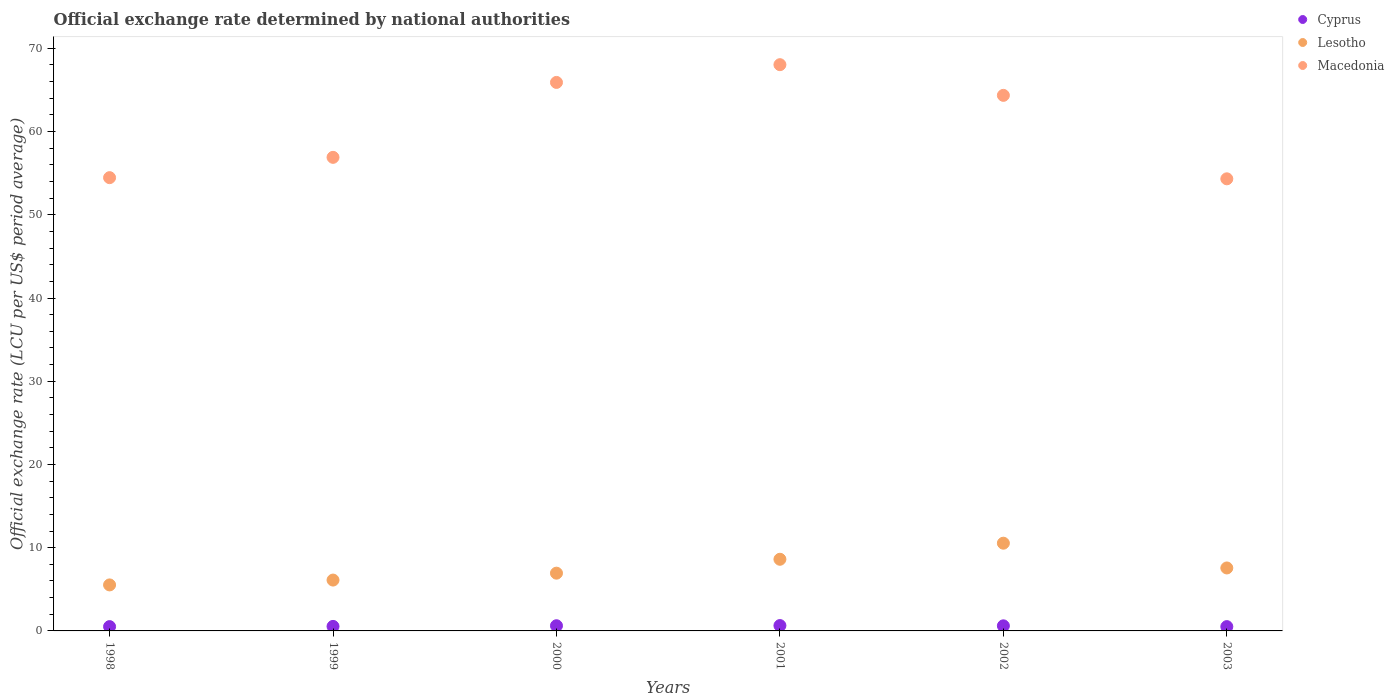How many different coloured dotlines are there?
Provide a succinct answer. 3. Is the number of dotlines equal to the number of legend labels?
Ensure brevity in your answer.  Yes. What is the official exchange rate in Macedonia in 1999?
Provide a short and direct response. 56.9. Across all years, what is the maximum official exchange rate in Lesotho?
Make the answer very short. 10.54. Across all years, what is the minimum official exchange rate in Macedonia?
Keep it short and to the point. 54.32. In which year was the official exchange rate in Macedonia maximum?
Offer a very short reply. 2001. What is the total official exchange rate in Cyprus in the graph?
Give a very brief answer. 3.45. What is the difference between the official exchange rate in Lesotho in 2000 and that in 2002?
Your response must be concise. -3.6. What is the difference between the official exchange rate in Cyprus in 2002 and the official exchange rate in Lesotho in 2003?
Ensure brevity in your answer.  -6.95. What is the average official exchange rate in Lesotho per year?
Your answer should be very brief. 7.55. In the year 2000, what is the difference between the official exchange rate in Lesotho and official exchange rate in Cyprus?
Ensure brevity in your answer.  6.32. What is the ratio of the official exchange rate in Lesotho in 1998 to that in 2003?
Offer a very short reply. 0.73. Is the official exchange rate in Cyprus in 1998 less than that in 2002?
Your answer should be very brief. Yes. What is the difference between the highest and the second highest official exchange rate in Lesotho?
Your response must be concise. 1.93. What is the difference between the highest and the lowest official exchange rate in Cyprus?
Make the answer very short. 0.13. In how many years, is the official exchange rate in Macedonia greater than the average official exchange rate in Macedonia taken over all years?
Give a very brief answer. 3. Does the official exchange rate in Macedonia monotonically increase over the years?
Provide a short and direct response. No. Is the official exchange rate in Macedonia strictly greater than the official exchange rate in Cyprus over the years?
Offer a terse response. Yes. Is the official exchange rate in Macedonia strictly less than the official exchange rate in Cyprus over the years?
Your answer should be compact. No. Does the graph contain any zero values?
Your response must be concise. No. Does the graph contain grids?
Keep it short and to the point. No. What is the title of the graph?
Your answer should be compact. Official exchange rate determined by national authorities. What is the label or title of the Y-axis?
Keep it short and to the point. Official exchange rate (LCU per US$ period average). What is the Official exchange rate (LCU per US$ period average) in Cyprus in 1998?
Offer a terse response. 0.52. What is the Official exchange rate (LCU per US$ period average) in Lesotho in 1998?
Provide a succinct answer. 5.53. What is the Official exchange rate (LCU per US$ period average) of Macedonia in 1998?
Ensure brevity in your answer.  54.46. What is the Official exchange rate (LCU per US$ period average) of Cyprus in 1999?
Give a very brief answer. 0.54. What is the Official exchange rate (LCU per US$ period average) of Lesotho in 1999?
Provide a short and direct response. 6.11. What is the Official exchange rate (LCU per US$ period average) of Macedonia in 1999?
Offer a terse response. 56.9. What is the Official exchange rate (LCU per US$ period average) in Cyprus in 2000?
Your response must be concise. 0.62. What is the Official exchange rate (LCU per US$ period average) in Lesotho in 2000?
Make the answer very short. 6.94. What is the Official exchange rate (LCU per US$ period average) in Macedonia in 2000?
Your answer should be very brief. 65.9. What is the Official exchange rate (LCU per US$ period average) of Cyprus in 2001?
Provide a succinct answer. 0.64. What is the Official exchange rate (LCU per US$ period average) of Lesotho in 2001?
Offer a terse response. 8.61. What is the Official exchange rate (LCU per US$ period average) of Macedonia in 2001?
Your answer should be compact. 68.04. What is the Official exchange rate (LCU per US$ period average) of Cyprus in 2002?
Give a very brief answer. 0.61. What is the Official exchange rate (LCU per US$ period average) in Lesotho in 2002?
Make the answer very short. 10.54. What is the Official exchange rate (LCU per US$ period average) in Macedonia in 2002?
Your response must be concise. 64.35. What is the Official exchange rate (LCU per US$ period average) in Cyprus in 2003?
Your answer should be very brief. 0.52. What is the Official exchange rate (LCU per US$ period average) in Lesotho in 2003?
Offer a terse response. 7.56. What is the Official exchange rate (LCU per US$ period average) of Macedonia in 2003?
Provide a short and direct response. 54.32. Across all years, what is the maximum Official exchange rate (LCU per US$ period average) of Cyprus?
Provide a succinct answer. 0.64. Across all years, what is the maximum Official exchange rate (LCU per US$ period average) of Lesotho?
Keep it short and to the point. 10.54. Across all years, what is the maximum Official exchange rate (LCU per US$ period average) in Macedonia?
Your answer should be compact. 68.04. Across all years, what is the minimum Official exchange rate (LCU per US$ period average) in Cyprus?
Your response must be concise. 0.52. Across all years, what is the minimum Official exchange rate (LCU per US$ period average) in Lesotho?
Your response must be concise. 5.53. Across all years, what is the minimum Official exchange rate (LCU per US$ period average) in Macedonia?
Provide a succinct answer. 54.32. What is the total Official exchange rate (LCU per US$ period average) of Cyprus in the graph?
Your answer should be compact. 3.45. What is the total Official exchange rate (LCU per US$ period average) in Lesotho in the graph?
Provide a succinct answer. 45.29. What is the total Official exchange rate (LCU per US$ period average) in Macedonia in the graph?
Your response must be concise. 363.98. What is the difference between the Official exchange rate (LCU per US$ period average) of Cyprus in 1998 and that in 1999?
Provide a succinct answer. -0.03. What is the difference between the Official exchange rate (LCU per US$ period average) in Lesotho in 1998 and that in 1999?
Keep it short and to the point. -0.58. What is the difference between the Official exchange rate (LCU per US$ period average) in Macedonia in 1998 and that in 1999?
Offer a very short reply. -2.44. What is the difference between the Official exchange rate (LCU per US$ period average) in Cyprus in 1998 and that in 2000?
Provide a succinct answer. -0.1. What is the difference between the Official exchange rate (LCU per US$ period average) in Lesotho in 1998 and that in 2000?
Your answer should be very brief. -1.41. What is the difference between the Official exchange rate (LCU per US$ period average) of Macedonia in 1998 and that in 2000?
Offer a terse response. -11.44. What is the difference between the Official exchange rate (LCU per US$ period average) in Cyprus in 1998 and that in 2001?
Provide a short and direct response. -0.13. What is the difference between the Official exchange rate (LCU per US$ period average) of Lesotho in 1998 and that in 2001?
Ensure brevity in your answer.  -3.08. What is the difference between the Official exchange rate (LCU per US$ period average) in Macedonia in 1998 and that in 2001?
Your answer should be compact. -13.58. What is the difference between the Official exchange rate (LCU per US$ period average) of Cyprus in 1998 and that in 2002?
Keep it short and to the point. -0.09. What is the difference between the Official exchange rate (LCU per US$ period average) of Lesotho in 1998 and that in 2002?
Your response must be concise. -5.01. What is the difference between the Official exchange rate (LCU per US$ period average) of Macedonia in 1998 and that in 2002?
Give a very brief answer. -9.89. What is the difference between the Official exchange rate (LCU per US$ period average) in Lesotho in 1998 and that in 2003?
Your answer should be very brief. -2.04. What is the difference between the Official exchange rate (LCU per US$ period average) in Macedonia in 1998 and that in 2003?
Give a very brief answer. 0.14. What is the difference between the Official exchange rate (LCU per US$ period average) of Cyprus in 1999 and that in 2000?
Ensure brevity in your answer.  -0.08. What is the difference between the Official exchange rate (LCU per US$ period average) in Lesotho in 1999 and that in 2000?
Your response must be concise. -0.83. What is the difference between the Official exchange rate (LCU per US$ period average) in Macedonia in 1999 and that in 2000?
Your response must be concise. -9. What is the difference between the Official exchange rate (LCU per US$ period average) in Cyprus in 1999 and that in 2001?
Your answer should be very brief. -0.1. What is the difference between the Official exchange rate (LCU per US$ period average) in Lesotho in 1999 and that in 2001?
Offer a very short reply. -2.5. What is the difference between the Official exchange rate (LCU per US$ period average) in Macedonia in 1999 and that in 2001?
Provide a short and direct response. -11.14. What is the difference between the Official exchange rate (LCU per US$ period average) in Cyprus in 1999 and that in 2002?
Provide a succinct answer. -0.07. What is the difference between the Official exchange rate (LCU per US$ period average) in Lesotho in 1999 and that in 2002?
Your answer should be very brief. -4.43. What is the difference between the Official exchange rate (LCU per US$ period average) of Macedonia in 1999 and that in 2002?
Provide a short and direct response. -7.45. What is the difference between the Official exchange rate (LCU per US$ period average) of Cyprus in 1999 and that in 2003?
Offer a terse response. 0.03. What is the difference between the Official exchange rate (LCU per US$ period average) in Lesotho in 1999 and that in 2003?
Your answer should be compact. -1.46. What is the difference between the Official exchange rate (LCU per US$ period average) in Macedonia in 1999 and that in 2003?
Your answer should be compact. 2.58. What is the difference between the Official exchange rate (LCU per US$ period average) in Cyprus in 2000 and that in 2001?
Your answer should be compact. -0.02. What is the difference between the Official exchange rate (LCU per US$ period average) of Lesotho in 2000 and that in 2001?
Provide a succinct answer. -1.67. What is the difference between the Official exchange rate (LCU per US$ period average) of Macedonia in 2000 and that in 2001?
Offer a terse response. -2.13. What is the difference between the Official exchange rate (LCU per US$ period average) of Cyprus in 2000 and that in 2002?
Provide a short and direct response. 0.01. What is the difference between the Official exchange rate (LCU per US$ period average) in Lesotho in 2000 and that in 2002?
Ensure brevity in your answer.  -3.6. What is the difference between the Official exchange rate (LCU per US$ period average) of Macedonia in 2000 and that in 2002?
Offer a terse response. 1.55. What is the difference between the Official exchange rate (LCU per US$ period average) of Cyprus in 2000 and that in 2003?
Provide a succinct answer. 0.1. What is the difference between the Official exchange rate (LCU per US$ period average) of Lesotho in 2000 and that in 2003?
Keep it short and to the point. -0.62. What is the difference between the Official exchange rate (LCU per US$ period average) in Macedonia in 2000 and that in 2003?
Offer a terse response. 11.58. What is the difference between the Official exchange rate (LCU per US$ period average) in Cyprus in 2001 and that in 2002?
Ensure brevity in your answer.  0.03. What is the difference between the Official exchange rate (LCU per US$ period average) in Lesotho in 2001 and that in 2002?
Make the answer very short. -1.93. What is the difference between the Official exchange rate (LCU per US$ period average) in Macedonia in 2001 and that in 2002?
Your answer should be compact. 3.69. What is the difference between the Official exchange rate (LCU per US$ period average) of Cyprus in 2001 and that in 2003?
Your answer should be compact. 0.13. What is the difference between the Official exchange rate (LCU per US$ period average) in Lesotho in 2001 and that in 2003?
Keep it short and to the point. 1.04. What is the difference between the Official exchange rate (LCU per US$ period average) of Macedonia in 2001 and that in 2003?
Your answer should be compact. 13.71. What is the difference between the Official exchange rate (LCU per US$ period average) in Cyprus in 2002 and that in 2003?
Make the answer very short. 0.09. What is the difference between the Official exchange rate (LCU per US$ period average) of Lesotho in 2002 and that in 2003?
Your response must be concise. 2.98. What is the difference between the Official exchange rate (LCU per US$ period average) of Macedonia in 2002 and that in 2003?
Offer a terse response. 10.03. What is the difference between the Official exchange rate (LCU per US$ period average) of Cyprus in 1998 and the Official exchange rate (LCU per US$ period average) of Lesotho in 1999?
Provide a short and direct response. -5.59. What is the difference between the Official exchange rate (LCU per US$ period average) in Cyprus in 1998 and the Official exchange rate (LCU per US$ period average) in Macedonia in 1999?
Your answer should be compact. -56.38. What is the difference between the Official exchange rate (LCU per US$ period average) in Lesotho in 1998 and the Official exchange rate (LCU per US$ period average) in Macedonia in 1999?
Your response must be concise. -51.37. What is the difference between the Official exchange rate (LCU per US$ period average) of Cyprus in 1998 and the Official exchange rate (LCU per US$ period average) of Lesotho in 2000?
Provide a succinct answer. -6.42. What is the difference between the Official exchange rate (LCU per US$ period average) in Cyprus in 1998 and the Official exchange rate (LCU per US$ period average) in Macedonia in 2000?
Offer a terse response. -65.39. What is the difference between the Official exchange rate (LCU per US$ period average) in Lesotho in 1998 and the Official exchange rate (LCU per US$ period average) in Macedonia in 2000?
Give a very brief answer. -60.38. What is the difference between the Official exchange rate (LCU per US$ period average) of Cyprus in 1998 and the Official exchange rate (LCU per US$ period average) of Lesotho in 2001?
Your answer should be compact. -8.09. What is the difference between the Official exchange rate (LCU per US$ period average) of Cyprus in 1998 and the Official exchange rate (LCU per US$ period average) of Macedonia in 2001?
Provide a succinct answer. -67.52. What is the difference between the Official exchange rate (LCU per US$ period average) of Lesotho in 1998 and the Official exchange rate (LCU per US$ period average) of Macedonia in 2001?
Provide a succinct answer. -62.51. What is the difference between the Official exchange rate (LCU per US$ period average) in Cyprus in 1998 and the Official exchange rate (LCU per US$ period average) in Lesotho in 2002?
Keep it short and to the point. -10.02. What is the difference between the Official exchange rate (LCU per US$ period average) in Cyprus in 1998 and the Official exchange rate (LCU per US$ period average) in Macedonia in 2002?
Your answer should be compact. -63.83. What is the difference between the Official exchange rate (LCU per US$ period average) of Lesotho in 1998 and the Official exchange rate (LCU per US$ period average) of Macedonia in 2002?
Make the answer very short. -58.82. What is the difference between the Official exchange rate (LCU per US$ period average) in Cyprus in 1998 and the Official exchange rate (LCU per US$ period average) in Lesotho in 2003?
Ensure brevity in your answer.  -7.05. What is the difference between the Official exchange rate (LCU per US$ period average) in Cyprus in 1998 and the Official exchange rate (LCU per US$ period average) in Macedonia in 2003?
Provide a short and direct response. -53.8. What is the difference between the Official exchange rate (LCU per US$ period average) of Lesotho in 1998 and the Official exchange rate (LCU per US$ period average) of Macedonia in 2003?
Keep it short and to the point. -48.79. What is the difference between the Official exchange rate (LCU per US$ period average) in Cyprus in 1999 and the Official exchange rate (LCU per US$ period average) in Lesotho in 2000?
Provide a succinct answer. -6.4. What is the difference between the Official exchange rate (LCU per US$ period average) in Cyprus in 1999 and the Official exchange rate (LCU per US$ period average) in Macedonia in 2000?
Provide a short and direct response. -65.36. What is the difference between the Official exchange rate (LCU per US$ period average) in Lesotho in 1999 and the Official exchange rate (LCU per US$ period average) in Macedonia in 2000?
Provide a short and direct response. -59.79. What is the difference between the Official exchange rate (LCU per US$ period average) in Cyprus in 1999 and the Official exchange rate (LCU per US$ period average) in Lesotho in 2001?
Offer a very short reply. -8.07. What is the difference between the Official exchange rate (LCU per US$ period average) of Cyprus in 1999 and the Official exchange rate (LCU per US$ period average) of Macedonia in 2001?
Offer a very short reply. -67.49. What is the difference between the Official exchange rate (LCU per US$ period average) of Lesotho in 1999 and the Official exchange rate (LCU per US$ period average) of Macedonia in 2001?
Offer a terse response. -61.93. What is the difference between the Official exchange rate (LCU per US$ period average) of Cyprus in 1999 and the Official exchange rate (LCU per US$ period average) of Lesotho in 2002?
Give a very brief answer. -10. What is the difference between the Official exchange rate (LCU per US$ period average) in Cyprus in 1999 and the Official exchange rate (LCU per US$ period average) in Macedonia in 2002?
Offer a very short reply. -63.81. What is the difference between the Official exchange rate (LCU per US$ period average) in Lesotho in 1999 and the Official exchange rate (LCU per US$ period average) in Macedonia in 2002?
Your answer should be compact. -58.24. What is the difference between the Official exchange rate (LCU per US$ period average) in Cyprus in 1999 and the Official exchange rate (LCU per US$ period average) in Lesotho in 2003?
Offer a very short reply. -7.02. What is the difference between the Official exchange rate (LCU per US$ period average) of Cyprus in 1999 and the Official exchange rate (LCU per US$ period average) of Macedonia in 2003?
Give a very brief answer. -53.78. What is the difference between the Official exchange rate (LCU per US$ period average) of Lesotho in 1999 and the Official exchange rate (LCU per US$ period average) of Macedonia in 2003?
Your answer should be compact. -48.21. What is the difference between the Official exchange rate (LCU per US$ period average) in Cyprus in 2000 and the Official exchange rate (LCU per US$ period average) in Lesotho in 2001?
Ensure brevity in your answer.  -7.99. What is the difference between the Official exchange rate (LCU per US$ period average) in Cyprus in 2000 and the Official exchange rate (LCU per US$ period average) in Macedonia in 2001?
Your answer should be very brief. -67.41. What is the difference between the Official exchange rate (LCU per US$ period average) of Lesotho in 2000 and the Official exchange rate (LCU per US$ period average) of Macedonia in 2001?
Your response must be concise. -61.1. What is the difference between the Official exchange rate (LCU per US$ period average) in Cyprus in 2000 and the Official exchange rate (LCU per US$ period average) in Lesotho in 2002?
Your response must be concise. -9.92. What is the difference between the Official exchange rate (LCU per US$ period average) of Cyprus in 2000 and the Official exchange rate (LCU per US$ period average) of Macedonia in 2002?
Provide a short and direct response. -63.73. What is the difference between the Official exchange rate (LCU per US$ period average) in Lesotho in 2000 and the Official exchange rate (LCU per US$ period average) in Macedonia in 2002?
Your answer should be compact. -57.41. What is the difference between the Official exchange rate (LCU per US$ period average) in Cyprus in 2000 and the Official exchange rate (LCU per US$ period average) in Lesotho in 2003?
Give a very brief answer. -6.94. What is the difference between the Official exchange rate (LCU per US$ period average) of Cyprus in 2000 and the Official exchange rate (LCU per US$ period average) of Macedonia in 2003?
Provide a succinct answer. -53.7. What is the difference between the Official exchange rate (LCU per US$ period average) of Lesotho in 2000 and the Official exchange rate (LCU per US$ period average) of Macedonia in 2003?
Offer a very short reply. -47.38. What is the difference between the Official exchange rate (LCU per US$ period average) of Cyprus in 2001 and the Official exchange rate (LCU per US$ period average) of Lesotho in 2002?
Your answer should be very brief. -9.9. What is the difference between the Official exchange rate (LCU per US$ period average) of Cyprus in 2001 and the Official exchange rate (LCU per US$ period average) of Macedonia in 2002?
Provide a short and direct response. -63.71. What is the difference between the Official exchange rate (LCU per US$ period average) of Lesotho in 2001 and the Official exchange rate (LCU per US$ period average) of Macedonia in 2002?
Your answer should be very brief. -55.74. What is the difference between the Official exchange rate (LCU per US$ period average) of Cyprus in 2001 and the Official exchange rate (LCU per US$ period average) of Lesotho in 2003?
Your answer should be compact. -6.92. What is the difference between the Official exchange rate (LCU per US$ period average) in Cyprus in 2001 and the Official exchange rate (LCU per US$ period average) in Macedonia in 2003?
Your answer should be very brief. -53.68. What is the difference between the Official exchange rate (LCU per US$ period average) in Lesotho in 2001 and the Official exchange rate (LCU per US$ period average) in Macedonia in 2003?
Your answer should be compact. -45.71. What is the difference between the Official exchange rate (LCU per US$ period average) of Cyprus in 2002 and the Official exchange rate (LCU per US$ period average) of Lesotho in 2003?
Make the answer very short. -6.95. What is the difference between the Official exchange rate (LCU per US$ period average) in Cyprus in 2002 and the Official exchange rate (LCU per US$ period average) in Macedonia in 2003?
Keep it short and to the point. -53.71. What is the difference between the Official exchange rate (LCU per US$ period average) in Lesotho in 2002 and the Official exchange rate (LCU per US$ period average) in Macedonia in 2003?
Provide a short and direct response. -43.78. What is the average Official exchange rate (LCU per US$ period average) of Cyprus per year?
Ensure brevity in your answer.  0.58. What is the average Official exchange rate (LCU per US$ period average) in Lesotho per year?
Make the answer very short. 7.55. What is the average Official exchange rate (LCU per US$ period average) in Macedonia per year?
Offer a very short reply. 60.66. In the year 1998, what is the difference between the Official exchange rate (LCU per US$ period average) of Cyprus and Official exchange rate (LCU per US$ period average) of Lesotho?
Offer a terse response. -5.01. In the year 1998, what is the difference between the Official exchange rate (LCU per US$ period average) of Cyprus and Official exchange rate (LCU per US$ period average) of Macedonia?
Your answer should be very brief. -53.94. In the year 1998, what is the difference between the Official exchange rate (LCU per US$ period average) in Lesotho and Official exchange rate (LCU per US$ period average) in Macedonia?
Your answer should be compact. -48.93. In the year 1999, what is the difference between the Official exchange rate (LCU per US$ period average) of Cyprus and Official exchange rate (LCU per US$ period average) of Lesotho?
Provide a succinct answer. -5.57. In the year 1999, what is the difference between the Official exchange rate (LCU per US$ period average) in Cyprus and Official exchange rate (LCU per US$ period average) in Macedonia?
Ensure brevity in your answer.  -56.36. In the year 1999, what is the difference between the Official exchange rate (LCU per US$ period average) in Lesotho and Official exchange rate (LCU per US$ period average) in Macedonia?
Keep it short and to the point. -50.79. In the year 2000, what is the difference between the Official exchange rate (LCU per US$ period average) in Cyprus and Official exchange rate (LCU per US$ period average) in Lesotho?
Your response must be concise. -6.32. In the year 2000, what is the difference between the Official exchange rate (LCU per US$ period average) of Cyprus and Official exchange rate (LCU per US$ period average) of Macedonia?
Provide a succinct answer. -65.28. In the year 2000, what is the difference between the Official exchange rate (LCU per US$ period average) in Lesotho and Official exchange rate (LCU per US$ period average) in Macedonia?
Give a very brief answer. -58.96. In the year 2001, what is the difference between the Official exchange rate (LCU per US$ period average) in Cyprus and Official exchange rate (LCU per US$ period average) in Lesotho?
Give a very brief answer. -7.97. In the year 2001, what is the difference between the Official exchange rate (LCU per US$ period average) of Cyprus and Official exchange rate (LCU per US$ period average) of Macedonia?
Offer a terse response. -67.39. In the year 2001, what is the difference between the Official exchange rate (LCU per US$ period average) in Lesotho and Official exchange rate (LCU per US$ period average) in Macedonia?
Your answer should be very brief. -59.43. In the year 2002, what is the difference between the Official exchange rate (LCU per US$ period average) of Cyprus and Official exchange rate (LCU per US$ period average) of Lesotho?
Provide a succinct answer. -9.93. In the year 2002, what is the difference between the Official exchange rate (LCU per US$ period average) in Cyprus and Official exchange rate (LCU per US$ period average) in Macedonia?
Your answer should be compact. -63.74. In the year 2002, what is the difference between the Official exchange rate (LCU per US$ period average) in Lesotho and Official exchange rate (LCU per US$ period average) in Macedonia?
Give a very brief answer. -53.81. In the year 2003, what is the difference between the Official exchange rate (LCU per US$ period average) in Cyprus and Official exchange rate (LCU per US$ period average) in Lesotho?
Your response must be concise. -7.05. In the year 2003, what is the difference between the Official exchange rate (LCU per US$ period average) in Cyprus and Official exchange rate (LCU per US$ period average) in Macedonia?
Ensure brevity in your answer.  -53.8. In the year 2003, what is the difference between the Official exchange rate (LCU per US$ period average) of Lesotho and Official exchange rate (LCU per US$ period average) of Macedonia?
Offer a very short reply. -46.76. What is the ratio of the Official exchange rate (LCU per US$ period average) of Cyprus in 1998 to that in 1999?
Give a very brief answer. 0.95. What is the ratio of the Official exchange rate (LCU per US$ period average) of Lesotho in 1998 to that in 1999?
Your response must be concise. 0.9. What is the ratio of the Official exchange rate (LCU per US$ period average) of Macedonia in 1998 to that in 1999?
Your response must be concise. 0.96. What is the ratio of the Official exchange rate (LCU per US$ period average) of Cyprus in 1998 to that in 2000?
Provide a succinct answer. 0.83. What is the ratio of the Official exchange rate (LCU per US$ period average) in Lesotho in 1998 to that in 2000?
Your response must be concise. 0.8. What is the ratio of the Official exchange rate (LCU per US$ period average) in Macedonia in 1998 to that in 2000?
Your response must be concise. 0.83. What is the ratio of the Official exchange rate (LCU per US$ period average) in Cyprus in 1998 to that in 2001?
Make the answer very short. 0.81. What is the ratio of the Official exchange rate (LCU per US$ period average) of Lesotho in 1998 to that in 2001?
Keep it short and to the point. 0.64. What is the ratio of the Official exchange rate (LCU per US$ period average) in Macedonia in 1998 to that in 2001?
Provide a short and direct response. 0.8. What is the ratio of the Official exchange rate (LCU per US$ period average) of Cyprus in 1998 to that in 2002?
Provide a succinct answer. 0.85. What is the ratio of the Official exchange rate (LCU per US$ period average) of Lesotho in 1998 to that in 2002?
Keep it short and to the point. 0.52. What is the ratio of the Official exchange rate (LCU per US$ period average) of Macedonia in 1998 to that in 2002?
Ensure brevity in your answer.  0.85. What is the ratio of the Official exchange rate (LCU per US$ period average) of Cyprus in 1998 to that in 2003?
Your response must be concise. 1. What is the ratio of the Official exchange rate (LCU per US$ period average) in Lesotho in 1998 to that in 2003?
Your response must be concise. 0.73. What is the ratio of the Official exchange rate (LCU per US$ period average) of Cyprus in 1999 to that in 2000?
Make the answer very short. 0.87. What is the ratio of the Official exchange rate (LCU per US$ period average) in Lesotho in 1999 to that in 2000?
Your answer should be very brief. 0.88. What is the ratio of the Official exchange rate (LCU per US$ period average) in Macedonia in 1999 to that in 2000?
Provide a short and direct response. 0.86. What is the ratio of the Official exchange rate (LCU per US$ period average) of Cyprus in 1999 to that in 2001?
Offer a very short reply. 0.84. What is the ratio of the Official exchange rate (LCU per US$ period average) of Lesotho in 1999 to that in 2001?
Keep it short and to the point. 0.71. What is the ratio of the Official exchange rate (LCU per US$ period average) in Macedonia in 1999 to that in 2001?
Ensure brevity in your answer.  0.84. What is the ratio of the Official exchange rate (LCU per US$ period average) in Cyprus in 1999 to that in 2002?
Offer a terse response. 0.89. What is the ratio of the Official exchange rate (LCU per US$ period average) of Lesotho in 1999 to that in 2002?
Provide a short and direct response. 0.58. What is the ratio of the Official exchange rate (LCU per US$ period average) in Macedonia in 1999 to that in 2002?
Your answer should be very brief. 0.88. What is the ratio of the Official exchange rate (LCU per US$ period average) in Cyprus in 1999 to that in 2003?
Ensure brevity in your answer.  1.05. What is the ratio of the Official exchange rate (LCU per US$ period average) in Lesotho in 1999 to that in 2003?
Make the answer very short. 0.81. What is the ratio of the Official exchange rate (LCU per US$ period average) of Macedonia in 1999 to that in 2003?
Ensure brevity in your answer.  1.05. What is the ratio of the Official exchange rate (LCU per US$ period average) of Cyprus in 2000 to that in 2001?
Provide a short and direct response. 0.97. What is the ratio of the Official exchange rate (LCU per US$ period average) in Lesotho in 2000 to that in 2001?
Provide a succinct answer. 0.81. What is the ratio of the Official exchange rate (LCU per US$ period average) in Macedonia in 2000 to that in 2001?
Provide a short and direct response. 0.97. What is the ratio of the Official exchange rate (LCU per US$ period average) of Cyprus in 2000 to that in 2002?
Ensure brevity in your answer.  1.02. What is the ratio of the Official exchange rate (LCU per US$ period average) in Lesotho in 2000 to that in 2002?
Offer a terse response. 0.66. What is the ratio of the Official exchange rate (LCU per US$ period average) of Macedonia in 2000 to that in 2002?
Ensure brevity in your answer.  1.02. What is the ratio of the Official exchange rate (LCU per US$ period average) in Cyprus in 2000 to that in 2003?
Your response must be concise. 1.2. What is the ratio of the Official exchange rate (LCU per US$ period average) in Lesotho in 2000 to that in 2003?
Your answer should be very brief. 0.92. What is the ratio of the Official exchange rate (LCU per US$ period average) in Macedonia in 2000 to that in 2003?
Provide a short and direct response. 1.21. What is the ratio of the Official exchange rate (LCU per US$ period average) in Cyprus in 2001 to that in 2002?
Your answer should be very brief. 1.05. What is the ratio of the Official exchange rate (LCU per US$ period average) in Lesotho in 2001 to that in 2002?
Offer a very short reply. 0.82. What is the ratio of the Official exchange rate (LCU per US$ period average) in Macedonia in 2001 to that in 2002?
Make the answer very short. 1.06. What is the ratio of the Official exchange rate (LCU per US$ period average) in Cyprus in 2001 to that in 2003?
Your response must be concise. 1.24. What is the ratio of the Official exchange rate (LCU per US$ period average) in Lesotho in 2001 to that in 2003?
Your response must be concise. 1.14. What is the ratio of the Official exchange rate (LCU per US$ period average) in Macedonia in 2001 to that in 2003?
Your answer should be compact. 1.25. What is the ratio of the Official exchange rate (LCU per US$ period average) in Cyprus in 2002 to that in 2003?
Offer a very short reply. 1.18. What is the ratio of the Official exchange rate (LCU per US$ period average) in Lesotho in 2002 to that in 2003?
Give a very brief answer. 1.39. What is the ratio of the Official exchange rate (LCU per US$ period average) in Macedonia in 2002 to that in 2003?
Provide a short and direct response. 1.18. What is the difference between the highest and the second highest Official exchange rate (LCU per US$ period average) of Cyprus?
Ensure brevity in your answer.  0.02. What is the difference between the highest and the second highest Official exchange rate (LCU per US$ period average) of Lesotho?
Make the answer very short. 1.93. What is the difference between the highest and the second highest Official exchange rate (LCU per US$ period average) of Macedonia?
Your answer should be very brief. 2.13. What is the difference between the highest and the lowest Official exchange rate (LCU per US$ period average) of Cyprus?
Ensure brevity in your answer.  0.13. What is the difference between the highest and the lowest Official exchange rate (LCU per US$ period average) in Lesotho?
Your response must be concise. 5.01. What is the difference between the highest and the lowest Official exchange rate (LCU per US$ period average) of Macedonia?
Your response must be concise. 13.71. 